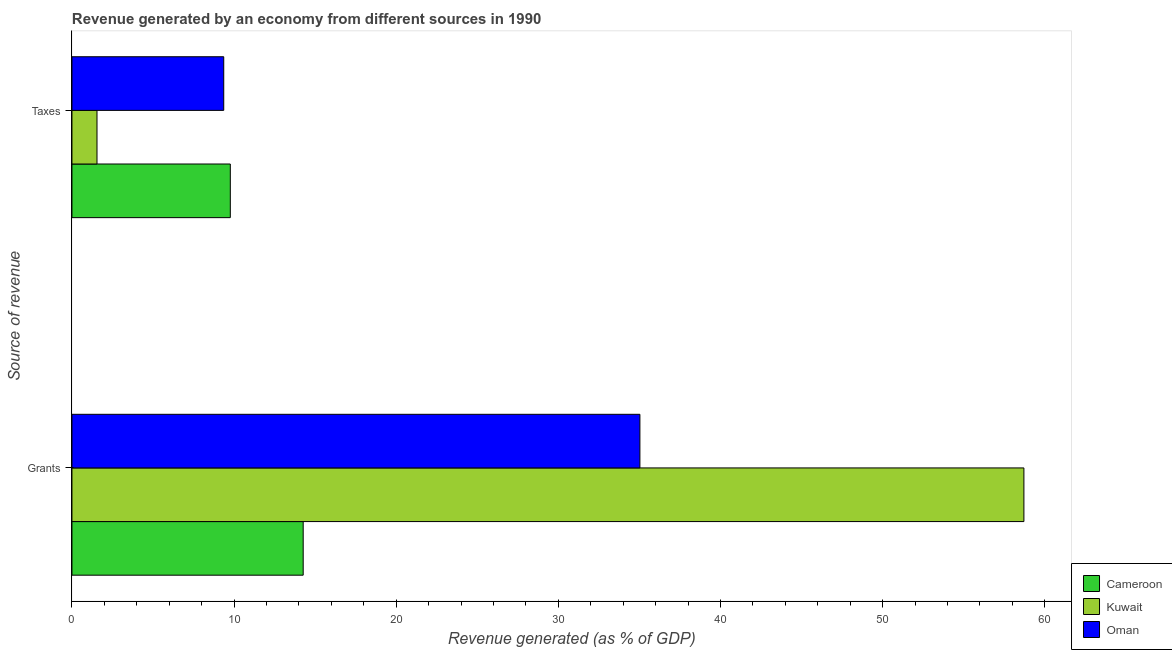How many different coloured bars are there?
Keep it short and to the point. 3. How many bars are there on the 2nd tick from the bottom?
Keep it short and to the point. 3. What is the label of the 1st group of bars from the top?
Your answer should be compact. Taxes. What is the revenue generated by grants in Kuwait?
Your answer should be compact. 58.71. Across all countries, what is the maximum revenue generated by taxes?
Give a very brief answer. 9.77. Across all countries, what is the minimum revenue generated by grants?
Your response must be concise. 14.26. In which country was the revenue generated by grants maximum?
Provide a short and direct response. Kuwait. In which country was the revenue generated by grants minimum?
Provide a short and direct response. Cameroon. What is the total revenue generated by taxes in the graph?
Make the answer very short. 20.67. What is the difference between the revenue generated by taxes in Oman and that in Cameroon?
Make the answer very short. -0.41. What is the difference between the revenue generated by taxes in Cameroon and the revenue generated by grants in Oman?
Your response must be concise. -25.26. What is the average revenue generated by taxes per country?
Keep it short and to the point. 6.89. What is the difference between the revenue generated by grants and revenue generated by taxes in Kuwait?
Provide a succinct answer. 57.17. In how many countries, is the revenue generated by grants greater than 46 %?
Make the answer very short. 1. What is the ratio of the revenue generated by taxes in Cameroon to that in Kuwait?
Offer a terse response. 6.32. In how many countries, is the revenue generated by grants greater than the average revenue generated by grants taken over all countries?
Offer a terse response. 1. What does the 2nd bar from the top in Grants represents?
Provide a short and direct response. Kuwait. What does the 1st bar from the bottom in Taxes represents?
Provide a succinct answer. Cameroon. How many countries are there in the graph?
Your answer should be compact. 3. Are the values on the major ticks of X-axis written in scientific E-notation?
Provide a succinct answer. No. What is the title of the graph?
Provide a short and direct response. Revenue generated by an economy from different sources in 1990. Does "West Bank and Gaza" appear as one of the legend labels in the graph?
Provide a short and direct response. No. What is the label or title of the X-axis?
Your answer should be very brief. Revenue generated (as % of GDP). What is the label or title of the Y-axis?
Ensure brevity in your answer.  Source of revenue. What is the Revenue generated (as % of GDP) in Cameroon in Grants?
Your response must be concise. 14.26. What is the Revenue generated (as % of GDP) of Kuwait in Grants?
Your answer should be compact. 58.71. What is the Revenue generated (as % of GDP) in Oman in Grants?
Your response must be concise. 35.03. What is the Revenue generated (as % of GDP) in Cameroon in Taxes?
Your answer should be compact. 9.77. What is the Revenue generated (as % of GDP) in Kuwait in Taxes?
Your response must be concise. 1.55. What is the Revenue generated (as % of GDP) in Oman in Taxes?
Ensure brevity in your answer.  9.36. Across all Source of revenue, what is the maximum Revenue generated (as % of GDP) of Cameroon?
Provide a succinct answer. 14.26. Across all Source of revenue, what is the maximum Revenue generated (as % of GDP) of Kuwait?
Your answer should be compact. 58.71. Across all Source of revenue, what is the maximum Revenue generated (as % of GDP) in Oman?
Offer a terse response. 35.03. Across all Source of revenue, what is the minimum Revenue generated (as % of GDP) of Cameroon?
Give a very brief answer. 9.77. Across all Source of revenue, what is the minimum Revenue generated (as % of GDP) of Kuwait?
Keep it short and to the point. 1.55. Across all Source of revenue, what is the minimum Revenue generated (as % of GDP) in Oman?
Give a very brief answer. 9.36. What is the total Revenue generated (as % of GDP) in Cameroon in the graph?
Your answer should be compact. 24.03. What is the total Revenue generated (as % of GDP) in Kuwait in the graph?
Your answer should be compact. 60.26. What is the total Revenue generated (as % of GDP) in Oman in the graph?
Give a very brief answer. 44.39. What is the difference between the Revenue generated (as % of GDP) of Cameroon in Grants and that in Taxes?
Give a very brief answer. 4.49. What is the difference between the Revenue generated (as % of GDP) in Kuwait in Grants and that in Taxes?
Ensure brevity in your answer.  57.17. What is the difference between the Revenue generated (as % of GDP) in Oman in Grants and that in Taxes?
Give a very brief answer. 25.67. What is the difference between the Revenue generated (as % of GDP) in Cameroon in Grants and the Revenue generated (as % of GDP) in Kuwait in Taxes?
Keep it short and to the point. 12.72. What is the difference between the Revenue generated (as % of GDP) of Cameroon in Grants and the Revenue generated (as % of GDP) of Oman in Taxes?
Keep it short and to the point. 4.9. What is the difference between the Revenue generated (as % of GDP) in Kuwait in Grants and the Revenue generated (as % of GDP) in Oman in Taxes?
Give a very brief answer. 49.35. What is the average Revenue generated (as % of GDP) in Cameroon per Source of revenue?
Give a very brief answer. 12.01. What is the average Revenue generated (as % of GDP) in Kuwait per Source of revenue?
Your answer should be very brief. 30.13. What is the average Revenue generated (as % of GDP) in Oman per Source of revenue?
Your response must be concise. 22.2. What is the difference between the Revenue generated (as % of GDP) of Cameroon and Revenue generated (as % of GDP) of Kuwait in Grants?
Your answer should be very brief. -44.45. What is the difference between the Revenue generated (as % of GDP) in Cameroon and Revenue generated (as % of GDP) in Oman in Grants?
Make the answer very short. -20.77. What is the difference between the Revenue generated (as % of GDP) of Kuwait and Revenue generated (as % of GDP) of Oman in Grants?
Offer a very short reply. 23.68. What is the difference between the Revenue generated (as % of GDP) of Cameroon and Revenue generated (as % of GDP) of Kuwait in Taxes?
Give a very brief answer. 8.22. What is the difference between the Revenue generated (as % of GDP) of Cameroon and Revenue generated (as % of GDP) of Oman in Taxes?
Keep it short and to the point. 0.41. What is the difference between the Revenue generated (as % of GDP) of Kuwait and Revenue generated (as % of GDP) of Oman in Taxes?
Keep it short and to the point. -7.82. What is the ratio of the Revenue generated (as % of GDP) of Cameroon in Grants to that in Taxes?
Make the answer very short. 1.46. What is the ratio of the Revenue generated (as % of GDP) in Oman in Grants to that in Taxes?
Your answer should be compact. 3.74. What is the difference between the highest and the second highest Revenue generated (as % of GDP) in Cameroon?
Provide a short and direct response. 4.49. What is the difference between the highest and the second highest Revenue generated (as % of GDP) of Kuwait?
Your response must be concise. 57.17. What is the difference between the highest and the second highest Revenue generated (as % of GDP) in Oman?
Give a very brief answer. 25.67. What is the difference between the highest and the lowest Revenue generated (as % of GDP) in Cameroon?
Your answer should be very brief. 4.49. What is the difference between the highest and the lowest Revenue generated (as % of GDP) of Kuwait?
Give a very brief answer. 57.17. What is the difference between the highest and the lowest Revenue generated (as % of GDP) in Oman?
Your answer should be compact. 25.67. 